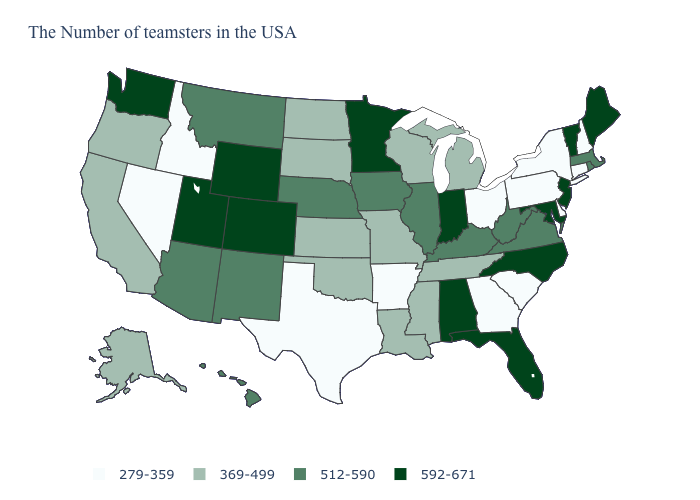Which states have the lowest value in the USA?
Be succinct. New Hampshire, Connecticut, New York, Delaware, Pennsylvania, South Carolina, Ohio, Georgia, Arkansas, Texas, Idaho, Nevada. Does the first symbol in the legend represent the smallest category?
Write a very short answer. Yes. What is the value of Oregon?
Keep it brief. 369-499. How many symbols are there in the legend?
Short answer required. 4. Among the states that border Washington , does Idaho have the lowest value?
Give a very brief answer. Yes. Name the states that have a value in the range 592-671?
Quick response, please. Maine, Vermont, New Jersey, Maryland, North Carolina, Florida, Indiana, Alabama, Minnesota, Wyoming, Colorado, Utah, Washington. Does Oklahoma have the lowest value in the USA?
Be succinct. No. Among the states that border Delaware , which have the highest value?
Answer briefly. New Jersey, Maryland. Does Maine have the highest value in the USA?
Write a very short answer. Yes. Name the states that have a value in the range 369-499?
Keep it brief. Michigan, Tennessee, Wisconsin, Mississippi, Louisiana, Missouri, Kansas, Oklahoma, South Dakota, North Dakota, California, Oregon, Alaska. Among the states that border Louisiana , does Mississippi have the lowest value?
Give a very brief answer. No. Name the states that have a value in the range 279-359?
Keep it brief. New Hampshire, Connecticut, New York, Delaware, Pennsylvania, South Carolina, Ohio, Georgia, Arkansas, Texas, Idaho, Nevada. Does Oregon have the highest value in the West?
Short answer required. No. What is the lowest value in the West?
Concise answer only. 279-359. Does Utah have the lowest value in the West?
Write a very short answer. No. 